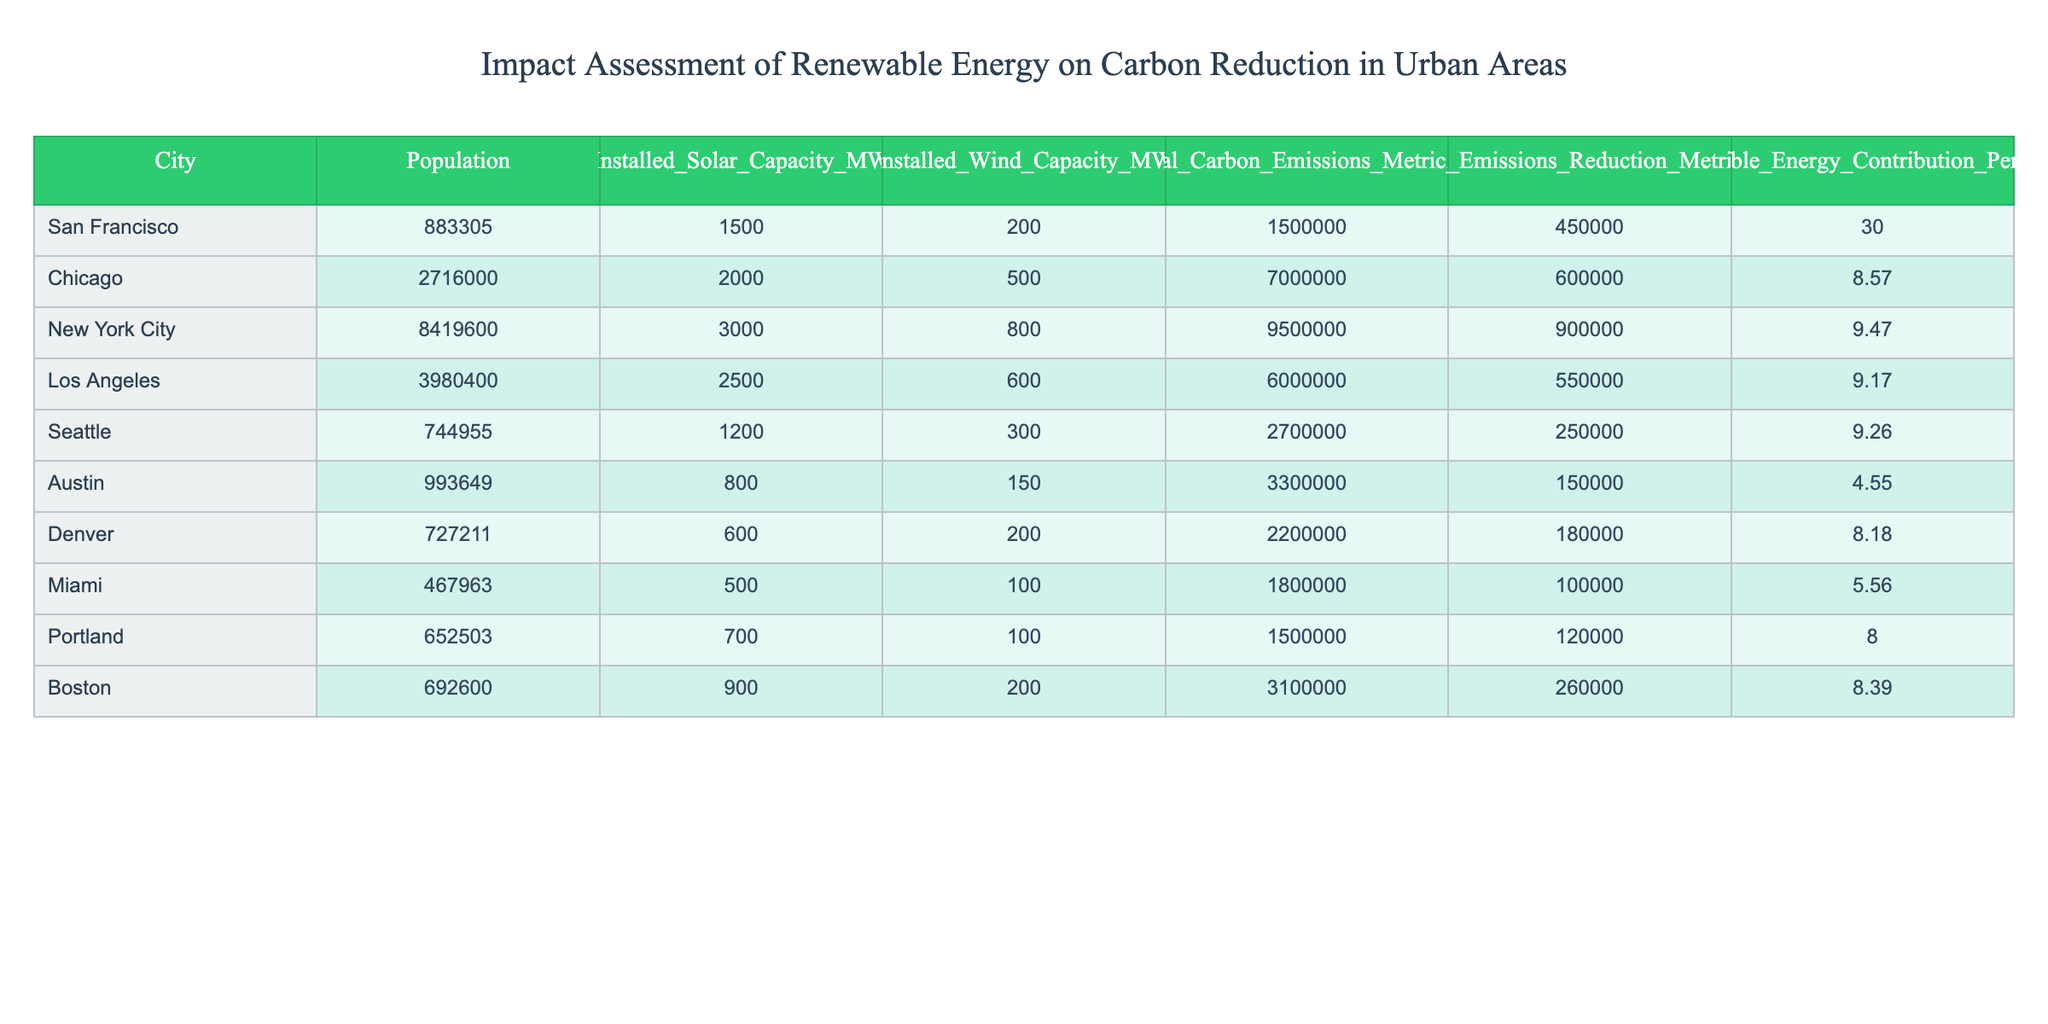What is the installed solar capacity in Chicago? The table shows that the installed solar capacity in Chicago is listed under the "Installed_Solar_Capacity_MW" column, which states the value is 2000 MW.
Answer: 2000 MW Which city has the highest annual carbon emissions? By comparing the "Annual_Carbon_Emissions_Metric_Tons" column for each city, New York City has the highest value at 9500000 metric tons.
Answer: New York City What is the difference in carbon emissions reduction between San Francisco and Austin? First, San Francisco's carbon emissions reduction is 450000 metric tons, while Austin's is 150000 metric tons. The difference is 450000 - 150000 = 300000 metric tons.
Answer: 300000 metric tons Is the contribution of renewable energy in Los Angeles greater than that in Seattle? For Los Angeles, the renewable energy contribution is 9.17%, and for Seattle, it is 9.26%. Since 9.17% is less than 9.26%, the statement is false.
Answer: No What is the average renewable energy contribution percentage across all cities? To find the average, first sum up the contribution percentages: 30 + 8.57 + 9.47 + 9.17 + 9.26 + 4.55 + 8.18 + 5.56 + 8.39 =  92.45. There are 10 cities, so 92.45 / 10 = 9.245%.
Answer: 9.25% Which city has the lowest installed wind capacity and what is that capacity? The table shows that Austin has the lowest installed wind capacity listed under the “Installed_Wind_Capacity_MW” column with a value of 150 MW.
Answer: 150 MW How much total carbon emissions reduction can be found in the cities with a population over 2 million? The cities over 2 million are Chicago (600000), New York City (900000), and Los Angeles (550000). Their reductions sum to 600000 + 900000 + 550000 = 2050000 metric tons.
Answer: 2050000 metric tons Is the carbon emissions reduction in Portland less than in Denver? Portland has a reduction of 120000 metric tons while Denver has a higher reduction of 180000 metric tons. Thus, the statement is true.
Answer: Yes What is the total annual carbon emissions of the five cities with the highest populations? The five cities with the highest populations are New York City (9500000), Los Angeles (6000000), Chicago (7000000), San Francisco (1500000), and Austin (3300000). Their total emissions are 9500000 + 6000000 + 7000000 + 1500000 + 3300000 = 28800000 metric tons.
Answer: 28800000 metric tons 